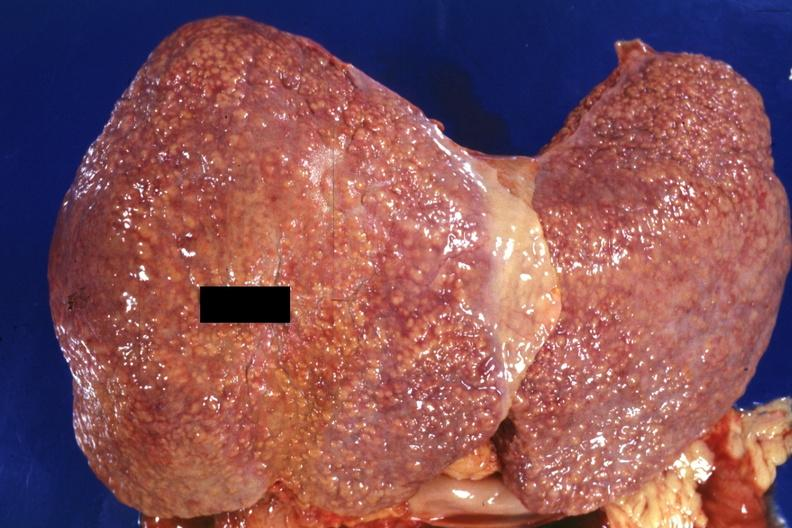does this image show external view of large liver with obvious cirrhosis excellent example?
Answer the question using a single word or phrase. Yes 